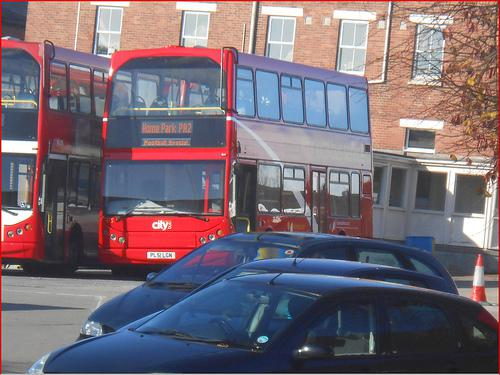Question: how many buses are visible?
Choices:
A. One.
B. Two.
C. Three.
D. Four.
Answer with the letter. Answer: B Question: what kind of vehicle are the red ones?
Choices:
A. Buses.
B. Cabs.
C. Planes.
D. Trains.
Answer with the letter. Answer: A Question: how are the buses parked?
Choices:
A. To the left.
B. Haphazardly.
C. In a row.
D. Side by side.
Answer with the letter. Answer: D Question: what type of buses are these?
Choices:
A. Yellow.
B. Broken.
C. Double Decker.
D. Toll.
Answer with the letter. Answer: C Question: who can drive the red vehicles?
Choices:
A. Anyone.
B. Bus drivers.
C. Policeman.
D. A cabbie.
Answer with the letter. Answer: B 